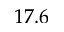Convert formula to latex. <formula><loc_0><loc_0><loc_500><loc_500>1 7 . 6</formula> 